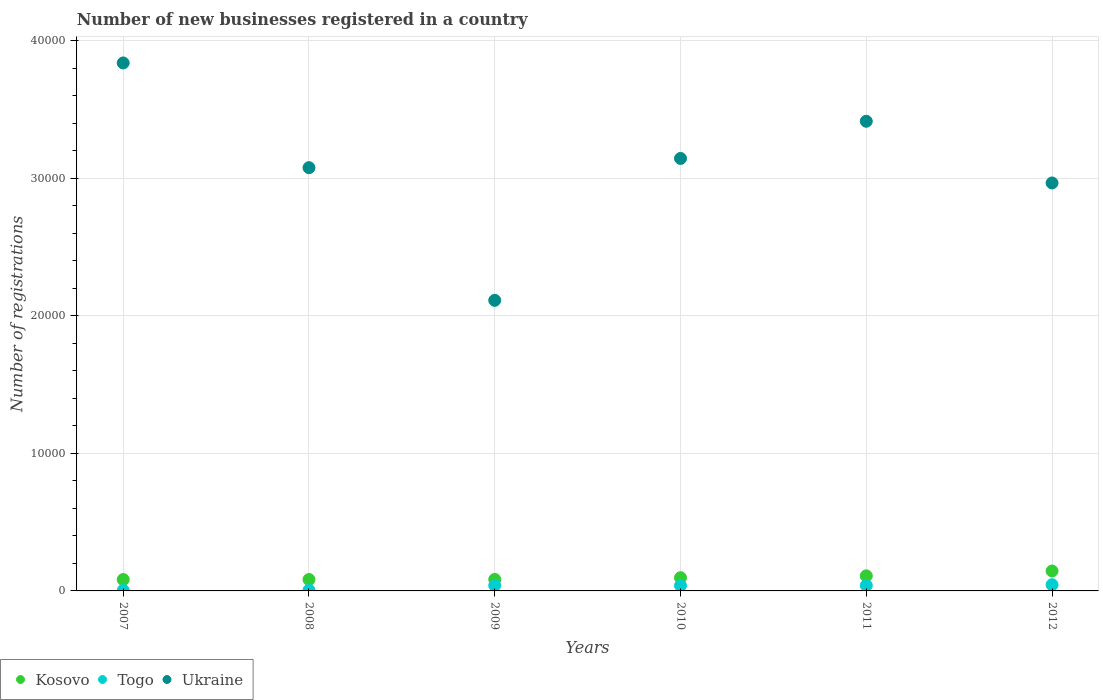How many different coloured dotlines are there?
Keep it short and to the point. 3. Is the number of dotlines equal to the number of legend labels?
Provide a short and direct response. Yes. What is the number of new businesses registered in Togo in 2010?
Your response must be concise. 388. Across all years, what is the maximum number of new businesses registered in Ukraine?
Your response must be concise. 3.84e+04. Across all years, what is the minimum number of new businesses registered in Kosovo?
Make the answer very short. 827. What is the total number of new businesses registered in Togo in the graph?
Your answer should be very brief. 1729. What is the difference between the number of new businesses registered in Togo in 2010 and the number of new businesses registered in Kosovo in 2012?
Ensure brevity in your answer.  -1061. What is the average number of new businesses registered in Ukraine per year?
Your answer should be very brief. 3.09e+04. In the year 2011, what is the difference between the number of new businesses registered in Kosovo and number of new businesses registered in Togo?
Your response must be concise. 697. What is the ratio of the number of new businesses registered in Kosovo in 2009 to that in 2011?
Your answer should be compact. 0.76. Is the number of new businesses registered in Togo in 2010 less than that in 2012?
Keep it short and to the point. Yes. Is the difference between the number of new businesses registered in Kosovo in 2007 and 2012 greater than the difference between the number of new businesses registered in Togo in 2007 and 2012?
Your answer should be compact. No. What is the difference between the highest and the second highest number of new businesses registered in Kosovo?
Provide a succinct answer. 354. What is the difference between the highest and the lowest number of new businesses registered in Togo?
Offer a very short reply. 412. Is the number of new businesses registered in Togo strictly greater than the number of new businesses registered in Ukraine over the years?
Offer a terse response. No. Is the number of new businesses registered in Togo strictly less than the number of new businesses registered in Kosovo over the years?
Give a very brief answer. Yes. How many years are there in the graph?
Provide a succinct answer. 6. What is the difference between two consecutive major ticks on the Y-axis?
Your answer should be compact. 10000. Does the graph contain any zero values?
Your answer should be compact. No. Does the graph contain grids?
Your response must be concise. Yes. Where does the legend appear in the graph?
Your answer should be very brief. Bottom left. How many legend labels are there?
Ensure brevity in your answer.  3. How are the legend labels stacked?
Your answer should be very brief. Horizontal. What is the title of the graph?
Your answer should be compact. Number of new businesses registered in a country. What is the label or title of the Y-axis?
Ensure brevity in your answer.  Number of registrations. What is the Number of registrations of Kosovo in 2007?
Make the answer very short. 827. What is the Number of registrations of Ukraine in 2007?
Provide a short and direct response. 3.84e+04. What is the Number of registrations in Kosovo in 2008?
Ensure brevity in your answer.  829. What is the Number of registrations of Togo in 2008?
Make the answer very short. 53. What is the Number of registrations in Ukraine in 2008?
Give a very brief answer. 3.08e+04. What is the Number of registrations in Kosovo in 2009?
Provide a short and direct response. 836. What is the Number of registrations in Ukraine in 2009?
Your answer should be compact. 2.11e+04. What is the Number of registrations in Kosovo in 2010?
Keep it short and to the point. 962. What is the Number of registrations of Togo in 2010?
Provide a succinct answer. 388. What is the Number of registrations of Ukraine in 2010?
Offer a very short reply. 3.14e+04. What is the Number of registrations of Kosovo in 2011?
Give a very brief answer. 1095. What is the Number of registrations of Togo in 2011?
Provide a succinct answer. 398. What is the Number of registrations of Ukraine in 2011?
Your answer should be very brief. 3.41e+04. What is the Number of registrations in Kosovo in 2012?
Provide a short and direct response. 1449. What is the Number of registrations of Togo in 2012?
Offer a terse response. 451. What is the Number of registrations in Ukraine in 2012?
Your answer should be very brief. 2.96e+04. Across all years, what is the maximum Number of registrations of Kosovo?
Provide a short and direct response. 1449. Across all years, what is the maximum Number of registrations of Togo?
Your answer should be very brief. 451. Across all years, what is the maximum Number of registrations in Ukraine?
Offer a very short reply. 3.84e+04. Across all years, what is the minimum Number of registrations of Kosovo?
Your response must be concise. 827. Across all years, what is the minimum Number of registrations in Ukraine?
Ensure brevity in your answer.  2.11e+04. What is the total Number of registrations of Kosovo in the graph?
Your answer should be compact. 5998. What is the total Number of registrations in Togo in the graph?
Offer a terse response. 1729. What is the total Number of registrations of Ukraine in the graph?
Keep it short and to the point. 1.85e+05. What is the difference between the Number of registrations of Togo in 2007 and that in 2008?
Your response must be concise. -14. What is the difference between the Number of registrations of Ukraine in 2007 and that in 2008?
Ensure brevity in your answer.  7611. What is the difference between the Number of registrations in Kosovo in 2007 and that in 2009?
Your answer should be compact. -9. What is the difference between the Number of registrations in Togo in 2007 and that in 2009?
Provide a short and direct response. -361. What is the difference between the Number of registrations of Ukraine in 2007 and that in 2009?
Your response must be concise. 1.73e+04. What is the difference between the Number of registrations in Kosovo in 2007 and that in 2010?
Provide a short and direct response. -135. What is the difference between the Number of registrations in Togo in 2007 and that in 2010?
Give a very brief answer. -349. What is the difference between the Number of registrations of Ukraine in 2007 and that in 2010?
Your response must be concise. 6940. What is the difference between the Number of registrations of Kosovo in 2007 and that in 2011?
Your answer should be very brief. -268. What is the difference between the Number of registrations in Togo in 2007 and that in 2011?
Your answer should be compact. -359. What is the difference between the Number of registrations in Ukraine in 2007 and that in 2011?
Provide a short and direct response. 4238. What is the difference between the Number of registrations in Kosovo in 2007 and that in 2012?
Give a very brief answer. -622. What is the difference between the Number of registrations of Togo in 2007 and that in 2012?
Provide a succinct answer. -412. What is the difference between the Number of registrations in Ukraine in 2007 and that in 2012?
Give a very brief answer. 8723. What is the difference between the Number of registrations in Togo in 2008 and that in 2009?
Offer a terse response. -347. What is the difference between the Number of registrations in Ukraine in 2008 and that in 2009?
Provide a succinct answer. 9642. What is the difference between the Number of registrations of Kosovo in 2008 and that in 2010?
Offer a very short reply. -133. What is the difference between the Number of registrations in Togo in 2008 and that in 2010?
Make the answer very short. -335. What is the difference between the Number of registrations in Ukraine in 2008 and that in 2010?
Your answer should be compact. -671. What is the difference between the Number of registrations in Kosovo in 2008 and that in 2011?
Your answer should be compact. -266. What is the difference between the Number of registrations of Togo in 2008 and that in 2011?
Give a very brief answer. -345. What is the difference between the Number of registrations in Ukraine in 2008 and that in 2011?
Offer a terse response. -3373. What is the difference between the Number of registrations in Kosovo in 2008 and that in 2012?
Ensure brevity in your answer.  -620. What is the difference between the Number of registrations of Togo in 2008 and that in 2012?
Your answer should be very brief. -398. What is the difference between the Number of registrations in Ukraine in 2008 and that in 2012?
Give a very brief answer. 1112. What is the difference between the Number of registrations in Kosovo in 2009 and that in 2010?
Provide a short and direct response. -126. What is the difference between the Number of registrations of Ukraine in 2009 and that in 2010?
Make the answer very short. -1.03e+04. What is the difference between the Number of registrations of Kosovo in 2009 and that in 2011?
Ensure brevity in your answer.  -259. What is the difference between the Number of registrations in Ukraine in 2009 and that in 2011?
Make the answer very short. -1.30e+04. What is the difference between the Number of registrations of Kosovo in 2009 and that in 2012?
Keep it short and to the point. -613. What is the difference between the Number of registrations of Togo in 2009 and that in 2012?
Offer a very short reply. -51. What is the difference between the Number of registrations in Ukraine in 2009 and that in 2012?
Your answer should be compact. -8530. What is the difference between the Number of registrations of Kosovo in 2010 and that in 2011?
Make the answer very short. -133. What is the difference between the Number of registrations in Ukraine in 2010 and that in 2011?
Your answer should be compact. -2702. What is the difference between the Number of registrations in Kosovo in 2010 and that in 2012?
Make the answer very short. -487. What is the difference between the Number of registrations of Togo in 2010 and that in 2012?
Provide a short and direct response. -63. What is the difference between the Number of registrations of Ukraine in 2010 and that in 2012?
Offer a terse response. 1783. What is the difference between the Number of registrations of Kosovo in 2011 and that in 2012?
Keep it short and to the point. -354. What is the difference between the Number of registrations in Togo in 2011 and that in 2012?
Your answer should be compact. -53. What is the difference between the Number of registrations in Ukraine in 2011 and that in 2012?
Keep it short and to the point. 4485. What is the difference between the Number of registrations in Kosovo in 2007 and the Number of registrations in Togo in 2008?
Ensure brevity in your answer.  774. What is the difference between the Number of registrations of Kosovo in 2007 and the Number of registrations of Ukraine in 2008?
Give a very brief answer. -2.99e+04. What is the difference between the Number of registrations in Togo in 2007 and the Number of registrations in Ukraine in 2008?
Ensure brevity in your answer.  -3.07e+04. What is the difference between the Number of registrations in Kosovo in 2007 and the Number of registrations in Togo in 2009?
Ensure brevity in your answer.  427. What is the difference between the Number of registrations of Kosovo in 2007 and the Number of registrations of Ukraine in 2009?
Give a very brief answer. -2.03e+04. What is the difference between the Number of registrations in Togo in 2007 and the Number of registrations in Ukraine in 2009?
Your response must be concise. -2.11e+04. What is the difference between the Number of registrations of Kosovo in 2007 and the Number of registrations of Togo in 2010?
Your answer should be compact. 439. What is the difference between the Number of registrations of Kosovo in 2007 and the Number of registrations of Ukraine in 2010?
Provide a succinct answer. -3.06e+04. What is the difference between the Number of registrations of Togo in 2007 and the Number of registrations of Ukraine in 2010?
Offer a terse response. -3.14e+04. What is the difference between the Number of registrations of Kosovo in 2007 and the Number of registrations of Togo in 2011?
Offer a very short reply. 429. What is the difference between the Number of registrations of Kosovo in 2007 and the Number of registrations of Ukraine in 2011?
Offer a terse response. -3.33e+04. What is the difference between the Number of registrations of Togo in 2007 and the Number of registrations of Ukraine in 2011?
Your answer should be compact. -3.41e+04. What is the difference between the Number of registrations of Kosovo in 2007 and the Number of registrations of Togo in 2012?
Your response must be concise. 376. What is the difference between the Number of registrations in Kosovo in 2007 and the Number of registrations in Ukraine in 2012?
Make the answer very short. -2.88e+04. What is the difference between the Number of registrations of Togo in 2007 and the Number of registrations of Ukraine in 2012?
Keep it short and to the point. -2.96e+04. What is the difference between the Number of registrations in Kosovo in 2008 and the Number of registrations in Togo in 2009?
Your answer should be compact. 429. What is the difference between the Number of registrations of Kosovo in 2008 and the Number of registrations of Ukraine in 2009?
Give a very brief answer. -2.03e+04. What is the difference between the Number of registrations in Togo in 2008 and the Number of registrations in Ukraine in 2009?
Give a very brief answer. -2.11e+04. What is the difference between the Number of registrations in Kosovo in 2008 and the Number of registrations in Togo in 2010?
Make the answer very short. 441. What is the difference between the Number of registrations of Kosovo in 2008 and the Number of registrations of Ukraine in 2010?
Your response must be concise. -3.06e+04. What is the difference between the Number of registrations in Togo in 2008 and the Number of registrations in Ukraine in 2010?
Make the answer very short. -3.14e+04. What is the difference between the Number of registrations of Kosovo in 2008 and the Number of registrations of Togo in 2011?
Offer a very short reply. 431. What is the difference between the Number of registrations of Kosovo in 2008 and the Number of registrations of Ukraine in 2011?
Give a very brief answer. -3.33e+04. What is the difference between the Number of registrations in Togo in 2008 and the Number of registrations in Ukraine in 2011?
Your answer should be very brief. -3.41e+04. What is the difference between the Number of registrations of Kosovo in 2008 and the Number of registrations of Togo in 2012?
Your response must be concise. 378. What is the difference between the Number of registrations of Kosovo in 2008 and the Number of registrations of Ukraine in 2012?
Keep it short and to the point. -2.88e+04. What is the difference between the Number of registrations of Togo in 2008 and the Number of registrations of Ukraine in 2012?
Provide a succinct answer. -2.96e+04. What is the difference between the Number of registrations of Kosovo in 2009 and the Number of registrations of Togo in 2010?
Your answer should be compact. 448. What is the difference between the Number of registrations in Kosovo in 2009 and the Number of registrations in Ukraine in 2010?
Provide a succinct answer. -3.06e+04. What is the difference between the Number of registrations in Togo in 2009 and the Number of registrations in Ukraine in 2010?
Provide a succinct answer. -3.10e+04. What is the difference between the Number of registrations in Kosovo in 2009 and the Number of registrations in Togo in 2011?
Offer a terse response. 438. What is the difference between the Number of registrations of Kosovo in 2009 and the Number of registrations of Ukraine in 2011?
Offer a terse response. -3.33e+04. What is the difference between the Number of registrations of Togo in 2009 and the Number of registrations of Ukraine in 2011?
Offer a terse response. -3.37e+04. What is the difference between the Number of registrations in Kosovo in 2009 and the Number of registrations in Togo in 2012?
Your answer should be very brief. 385. What is the difference between the Number of registrations in Kosovo in 2009 and the Number of registrations in Ukraine in 2012?
Offer a terse response. -2.88e+04. What is the difference between the Number of registrations of Togo in 2009 and the Number of registrations of Ukraine in 2012?
Offer a terse response. -2.92e+04. What is the difference between the Number of registrations of Kosovo in 2010 and the Number of registrations of Togo in 2011?
Ensure brevity in your answer.  564. What is the difference between the Number of registrations of Kosovo in 2010 and the Number of registrations of Ukraine in 2011?
Provide a succinct answer. -3.32e+04. What is the difference between the Number of registrations of Togo in 2010 and the Number of registrations of Ukraine in 2011?
Your response must be concise. -3.37e+04. What is the difference between the Number of registrations in Kosovo in 2010 and the Number of registrations in Togo in 2012?
Keep it short and to the point. 511. What is the difference between the Number of registrations of Kosovo in 2010 and the Number of registrations of Ukraine in 2012?
Ensure brevity in your answer.  -2.87e+04. What is the difference between the Number of registrations of Togo in 2010 and the Number of registrations of Ukraine in 2012?
Your response must be concise. -2.93e+04. What is the difference between the Number of registrations of Kosovo in 2011 and the Number of registrations of Togo in 2012?
Keep it short and to the point. 644. What is the difference between the Number of registrations of Kosovo in 2011 and the Number of registrations of Ukraine in 2012?
Provide a succinct answer. -2.86e+04. What is the difference between the Number of registrations in Togo in 2011 and the Number of registrations in Ukraine in 2012?
Provide a succinct answer. -2.93e+04. What is the average Number of registrations in Kosovo per year?
Keep it short and to the point. 999.67. What is the average Number of registrations of Togo per year?
Make the answer very short. 288.17. What is the average Number of registrations of Ukraine per year?
Make the answer very short. 3.09e+04. In the year 2007, what is the difference between the Number of registrations in Kosovo and Number of registrations in Togo?
Offer a very short reply. 788. In the year 2007, what is the difference between the Number of registrations in Kosovo and Number of registrations in Ukraine?
Give a very brief answer. -3.75e+04. In the year 2007, what is the difference between the Number of registrations in Togo and Number of registrations in Ukraine?
Your answer should be compact. -3.83e+04. In the year 2008, what is the difference between the Number of registrations in Kosovo and Number of registrations in Togo?
Provide a succinct answer. 776. In the year 2008, what is the difference between the Number of registrations in Kosovo and Number of registrations in Ukraine?
Make the answer very short. -2.99e+04. In the year 2008, what is the difference between the Number of registrations of Togo and Number of registrations of Ukraine?
Keep it short and to the point. -3.07e+04. In the year 2009, what is the difference between the Number of registrations of Kosovo and Number of registrations of Togo?
Keep it short and to the point. 436. In the year 2009, what is the difference between the Number of registrations of Kosovo and Number of registrations of Ukraine?
Ensure brevity in your answer.  -2.03e+04. In the year 2009, what is the difference between the Number of registrations in Togo and Number of registrations in Ukraine?
Offer a terse response. -2.07e+04. In the year 2010, what is the difference between the Number of registrations of Kosovo and Number of registrations of Togo?
Offer a very short reply. 574. In the year 2010, what is the difference between the Number of registrations of Kosovo and Number of registrations of Ukraine?
Make the answer very short. -3.05e+04. In the year 2010, what is the difference between the Number of registrations of Togo and Number of registrations of Ukraine?
Keep it short and to the point. -3.10e+04. In the year 2011, what is the difference between the Number of registrations in Kosovo and Number of registrations in Togo?
Ensure brevity in your answer.  697. In the year 2011, what is the difference between the Number of registrations of Kosovo and Number of registrations of Ukraine?
Ensure brevity in your answer.  -3.30e+04. In the year 2011, what is the difference between the Number of registrations in Togo and Number of registrations in Ukraine?
Your response must be concise. -3.37e+04. In the year 2012, what is the difference between the Number of registrations of Kosovo and Number of registrations of Togo?
Provide a succinct answer. 998. In the year 2012, what is the difference between the Number of registrations of Kosovo and Number of registrations of Ukraine?
Your answer should be compact. -2.82e+04. In the year 2012, what is the difference between the Number of registrations in Togo and Number of registrations in Ukraine?
Offer a very short reply. -2.92e+04. What is the ratio of the Number of registrations of Togo in 2007 to that in 2008?
Your answer should be very brief. 0.74. What is the ratio of the Number of registrations in Ukraine in 2007 to that in 2008?
Offer a terse response. 1.25. What is the ratio of the Number of registrations in Kosovo in 2007 to that in 2009?
Make the answer very short. 0.99. What is the ratio of the Number of registrations of Togo in 2007 to that in 2009?
Your answer should be compact. 0.1. What is the ratio of the Number of registrations in Ukraine in 2007 to that in 2009?
Your answer should be compact. 1.82. What is the ratio of the Number of registrations of Kosovo in 2007 to that in 2010?
Offer a very short reply. 0.86. What is the ratio of the Number of registrations in Togo in 2007 to that in 2010?
Your answer should be compact. 0.1. What is the ratio of the Number of registrations of Ukraine in 2007 to that in 2010?
Offer a terse response. 1.22. What is the ratio of the Number of registrations of Kosovo in 2007 to that in 2011?
Provide a succinct answer. 0.76. What is the ratio of the Number of registrations in Togo in 2007 to that in 2011?
Your response must be concise. 0.1. What is the ratio of the Number of registrations of Ukraine in 2007 to that in 2011?
Give a very brief answer. 1.12. What is the ratio of the Number of registrations of Kosovo in 2007 to that in 2012?
Your answer should be compact. 0.57. What is the ratio of the Number of registrations of Togo in 2007 to that in 2012?
Your answer should be compact. 0.09. What is the ratio of the Number of registrations in Ukraine in 2007 to that in 2012?
Offer a terse response. 1.29. What is the ratio of the Number of registrations of Kosovo in 2008 to that in 2009?
Provide a short and direct response. 0.99. What is the ratio of the Number of registrations in Togo in 2008 to that in 2009?
Your answer should be very brief. 0.13. What is the ratio of the Number of registrations in Ukraine in 2008 to that in 2009?
Keep it short and to the point. 1.46. What is the ratio of the Number of registrations in Kosovo in 2008 to that in 2010?
Offer a very short reply. 0.86. What is the ratio of the Number of registrations of Togo in 2008 to that in 2010?
Your answer should be very brief. 0.14. What is the ratio of the Number of registrations in Ukraine in 2008 to that in 2010?
Provide a succinct answer. 0.98. What is the ratio of the Number of registrations of Kosovo in 2008 to that in 2011?
Offer a terse response. 0.76. What is the ratio of the Number of registrations of Togo in 2008 to that in 2011?
Provide a succinct answer. 0.13. What is the ratio of the Number of registrations in Ukraine in 2008 to that in 2011?
Keep it short and to the point. 0.9. What is the ratio of the Number of registrations of Kosovo in 2008 to that in 2012?
Provide a succinct answer. 0.57. What is the ratio of the Number of registrations in Togo in 2008 to that in 2012?
Provide a short and direct response. 0.12. What is the ratio of the Number of registrations of Ukraine in 2008 to that in 2012?
Give a very brief answer. 1.04. What is the ratio of the Number of registrations in Kosovo in 2009 to that in 2010?
Provide a succinct answer. 0.87. What is the ratio of the Number of registrations of Togo in 2009 to that in 2010?
Give a very brief answer. 1.03. What is the ratio of the Number of registrations of Ukraine in 2009 to that in 2010?
Offer a very short reply. 0.67. What is the ratio of the Number of registrations in Kosovo in 2009 to that in 2011?
Your answer should be very brief. 0.76. What is the ratio of the Number of registrations of Togo in 2009 to that in 2011?
Ensure brevity in your answer.  1. What is the ratio of the Number of registrations of Ukraine in 2009 to that in 2011?
Offer a terse response. 0.62. What is the ratio of the Number of registrations of Kosovo in 2009 to that in 2012?
Ensure brevity in your answer.  0.58. What is the ratio of the Number of registrations of Togo in 2009 to that in 2012?
Your answer should be very brief. 0.89. What is the ratio of the Number of registrations of Ukraine in 2009 to that in 2012?
Ensure brevity in your answer.  0.71. What is the ratio of the Number of registrations in Kosovo in 2010 to that in 2011?
Give a very brief answer. 0.88. What is the ratio of the Number of registrations in Togo in 2010 to that in 2011?
Your answer should be compact. 0.97. What is the ratio of the Number of registrations in Ukraine in 2010 to that in 2011?
Provide a short and direct response. 0.92. What is the ratio of the Number of registrations in Kosovo in 2010 to that in 2012?
Make the answer very short. 0.66. What is the ratio of the Number of registrations in Togo in 2010 to that in 2012?
Offer a terse response. 0.86. What is the ratio of the Number of registrations of Ukraine in 2010 to that in 2012?
Make the answer very short. 1.06. What is the ratio of the Number of registrations in Kosovo in 2011 to that in 2012?
Offer a very short reply. 0.76. What is the ratio of the Number of registrations in Togo in 2011 to that in 2012?
Make the answer very short. 0.88. What is the ratio of the Number of registrations in Ukraine in 2011 to that in 2012?
Offer a very short reply. 1.15. What is the difference between the highest and the second highest Number of registrations of Kosovo?
Provide a short and direct response. 354. What is the difference between the highest and the second highest Number of registrations of Togo?
Your answer should be compact. 51. What is the difference between the highest and the second highest Number of registrations in Ukraine?
Give a very brief answer. 4238. What is the difference between the highest and the lowest Number of registrations in Kosovo?
Keep it short and to the point. 622. What is the difference between the highest and the lowest Number of registrations of Togo?
Your answer should be very brief. 412. What is the difference between the highest and the lowest Number of registrations in Ukraine?
Ensure brevity in your answer.  1.73e+04. 